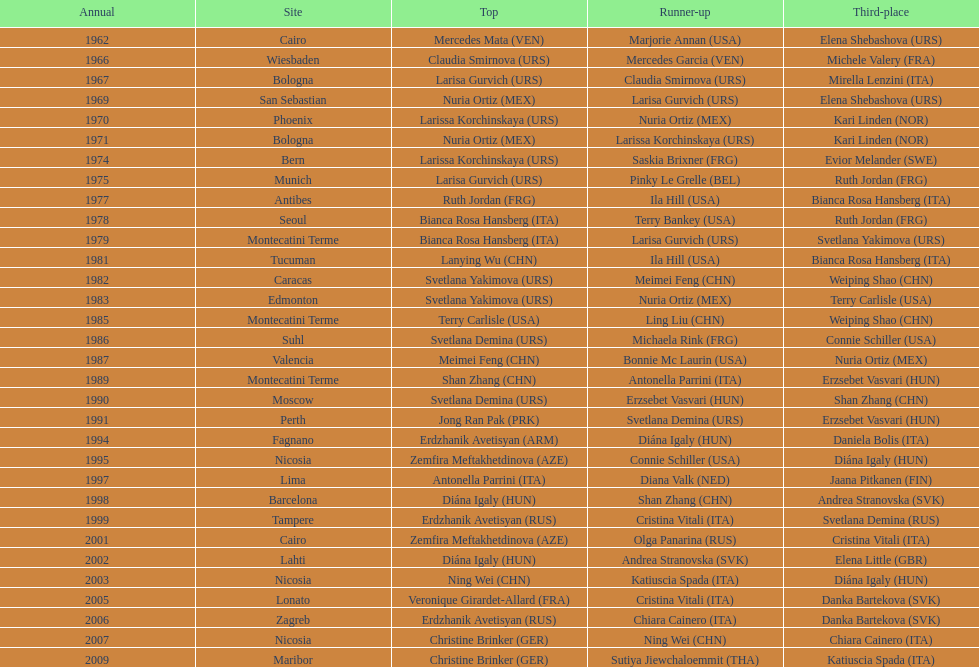Which country has the most bronze medals? Italy. 